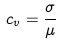<formula> <loc_0><loc_0><loc_500><loc_500>c _ { v } = \frac { \sigma } { \mu }</formula> 